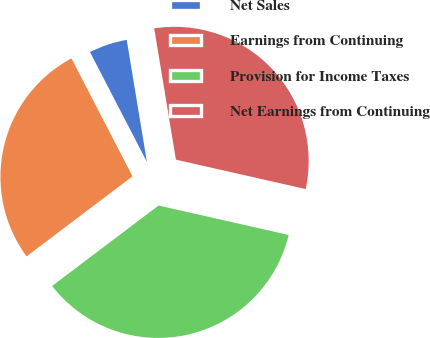Convert chart to OTSL. <chart><loc_0><loc_0><loc_500><loc_500><pie_chart><fcel>Net Sales<fcel>Earnings from Continuing<fcel>Provision for Income Taxes<fcel>Net Earnings from Continuing<nl><fcel>5.0%<fcel>27.69%<fcel>36.15%<fcel>31.15%<nl></chart> 